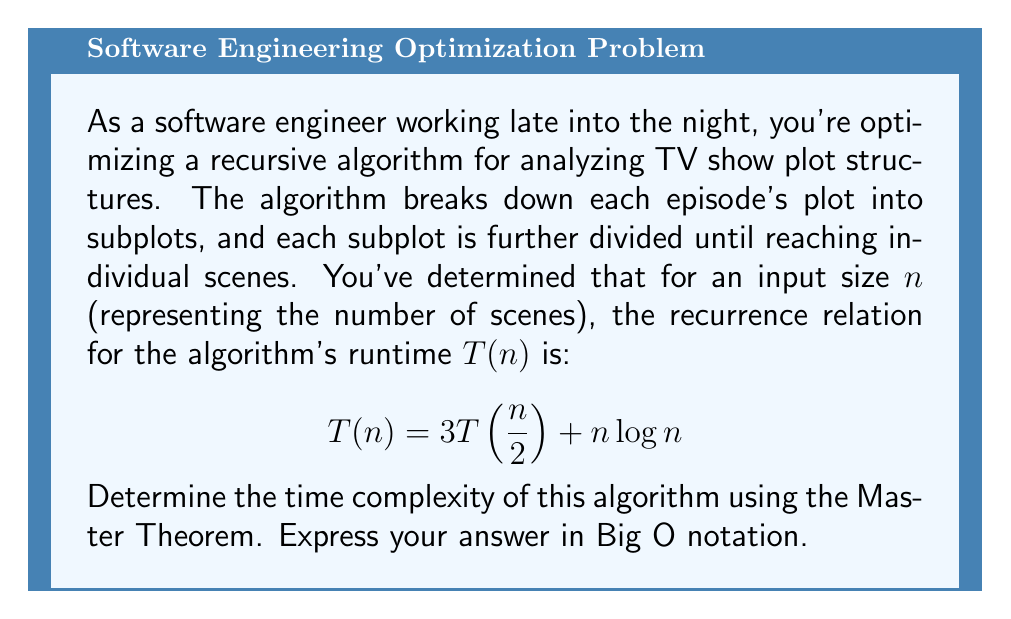Teach me how to tackle this problem. To solve this problem, we'll use the Master Theorem, which is perfect for analyzing the time complexity of recursive algorithms. The Master Theorem applies to recurrence relations of the form:

$$T(n) = aT(\frac{n}{b}) + f(n)$$

where $a \geq 1$, $b > 1$, and $f(n)$ is a positive function.

In our case:
$a = 3$
$b = 2$
$f(n) = n\log n$

The Master Theorem compares $n^{\log_b a}$ with $f(n)$:

1. Calculate $n^{\log_b a}$:
   $$n^{\log_b a} = n^{\log_2 3} \approx n^{1.58}$$

2. Compare $n^{\log_b a}$ with $f(n)$:
   $n^{\log_2 3} \approx n^{1.58}$ is asymptotically smaller than $n\log n$

This corresponds to Case 3 of the Master Theorem:
If $f(n) = \Omega(n^{\log_b a + \epsilon})$ for some constant $\epsilon > 0$, and if $af(\frac{n}{b}) \leq kf(n)$ for some constant $k < 1$ and all sufficiently large $n$, then $T(n) = \Theta(f(n))$.

Let's verify the second condition:
$$af(\frac{n}{b}) = 3(\frac{n}{2}\log\frac{n}{2}) = \frac{3n}{2}(\log n - 1) < \frac{3n}{2}\log n$$

For large $n$, this is indeed less than $kn\log n$ for some $k < 1$.

Therefore, we can conclude that $T(n) = \Theta(n\log n)$.
Answer: $O(n\log n)$ 